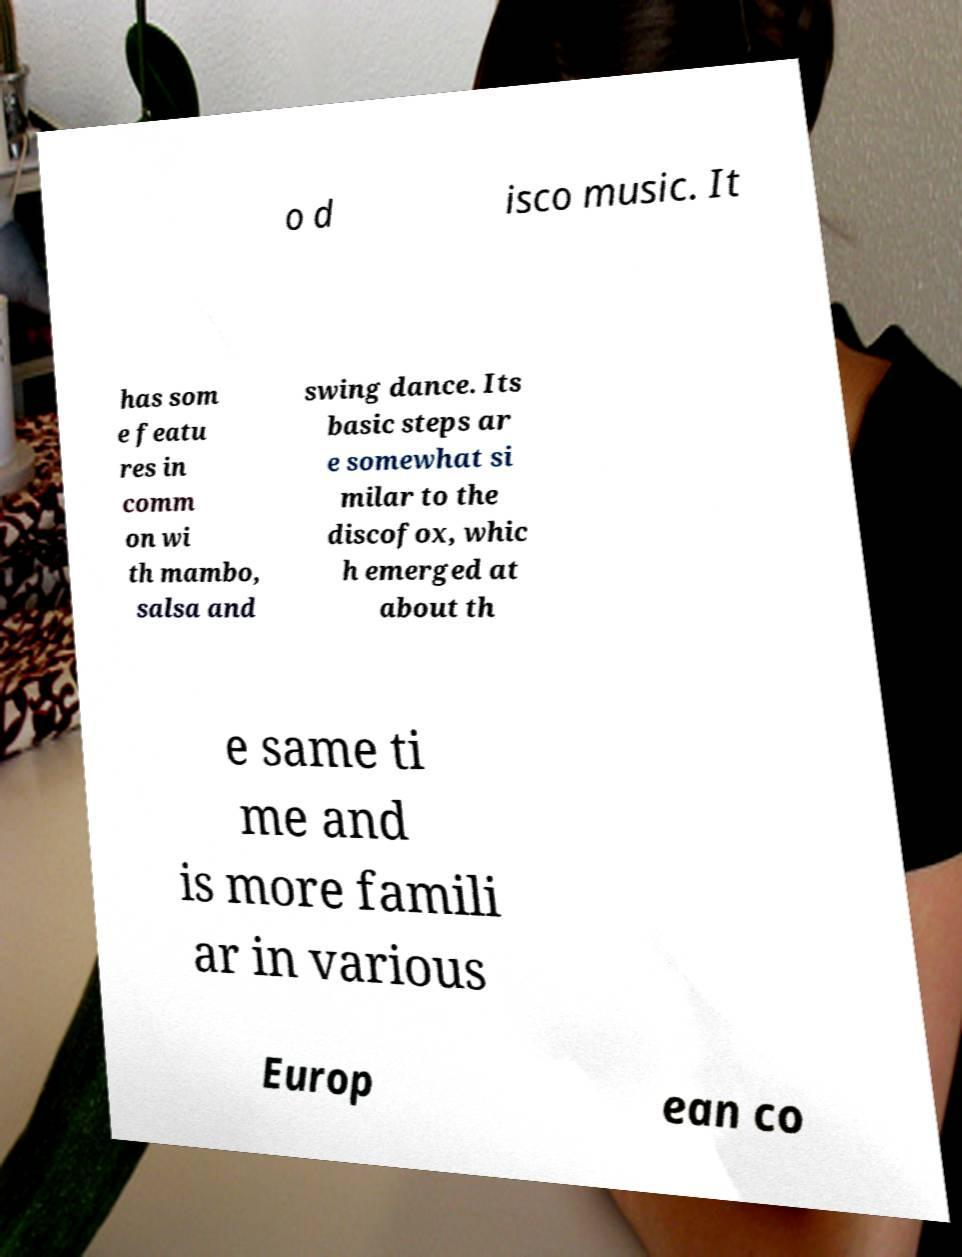Could you extract and type out the text from this image? o d isco music. It has som e featu res in comm on wi th mambo, salsa and swing dance. Its basic steps ar e somewhat si milar to the discofox, whic h emerged at about th e same ti me and is more famili ar in various Europ ean co 